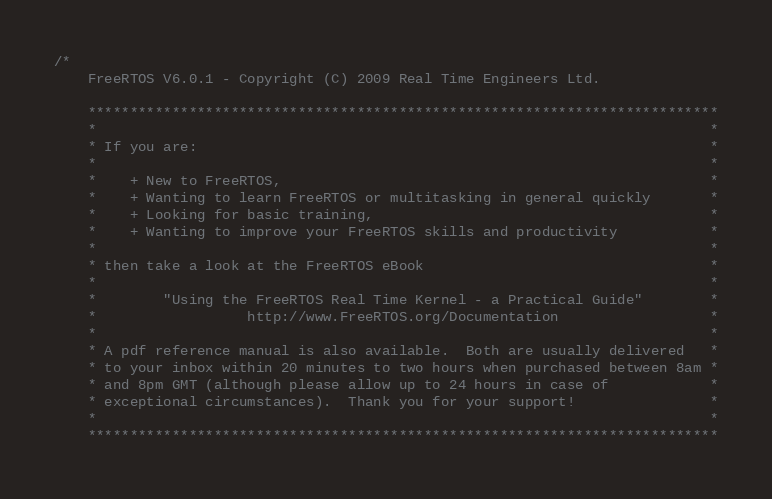Convert code to text. <code><loc_0><loc_0><loc_500><loc_500><_C_>/*
    FreeRTOS V6.0.1 - Copyright (C) 2009 Real Time Engineers Ltd.

    ***************************************************************************
    *                                                                         *
    * If you are:                                                             *
    *                                                                         *
    *    + New to FreeRTOS,                                                   *
    *    + Wanting to learn FreeRTOS or multitasking in general quickly       *
    *    + Looking for basic training,                                        *
    *    + Wanting to improve your FreeRTOS skills and productivity           *
    *                                                                         *
    * then take a look at the FreeRTOS eBook                                  *
    *                                                                         *
    *        "Using the FreeRTOS Real Time Kernel - a Practical Guide"        *
    *                  http://www.FreeRTOS.org/Documentation                  *
    *                                                                         *
    * A pdf reference manual is also available.  Both are usually delivered   *
    * to your inbox within 20 minutes to two hours when purchased between 8am *
    * and 8pm GMT (although please allow up to 24 hours in case of            *
    * exceptional circumstances).  Thank you for your support!                *
    *                                                                         *
    ***************************************************************************
</code> 